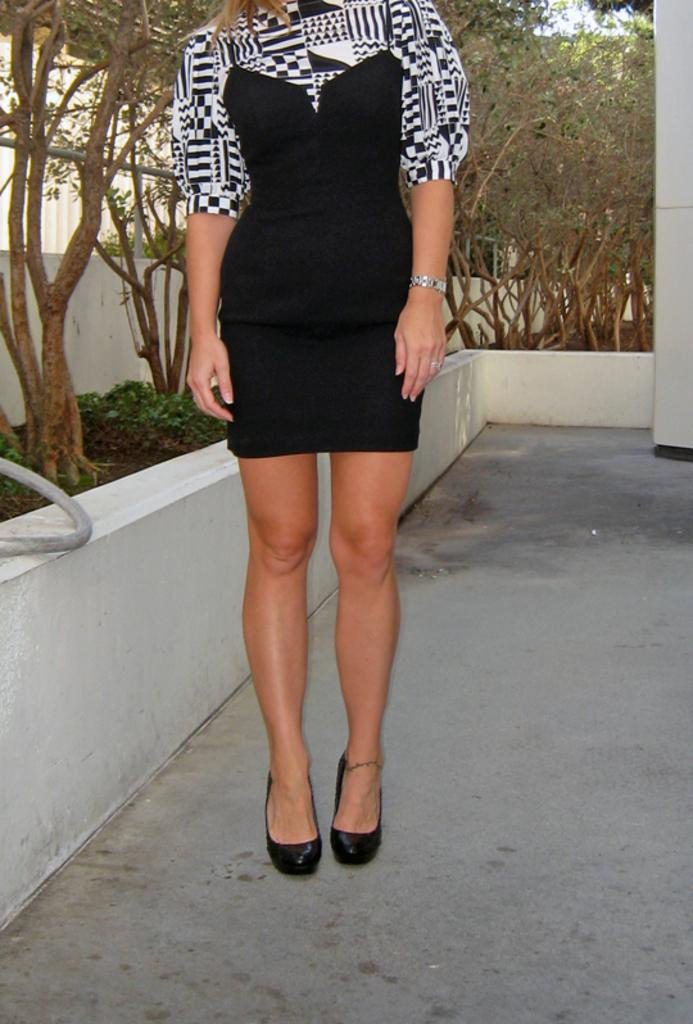What is the main subject of the image? There is a lady standing in the image. What can be seen in the background of the image? There are plants and a wall in the background of the image. What is visible at the bottom of the image? The floor is visible at the bottom of the image. What type of protest is happening in the image? There is no protest present in the image; it features a lady standing with plants and a wall in the background. Can you describe the machine that the lady is operating in the image? There is no machine present in the image; the lady is simply standing. 